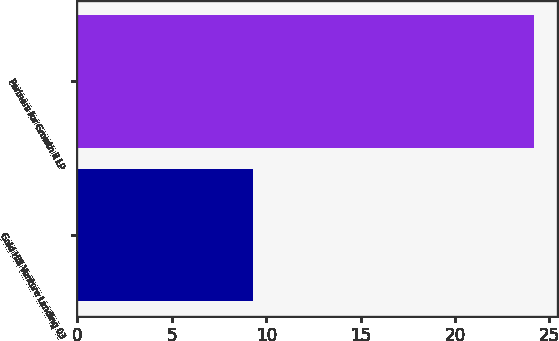<chart> <loc_0><loc_0><loc_500><loc_500><bar_chart><fcel>Gold Hill Venture Lending 03<fcel>Partners for Growth II LP<nl><fcel>9.3<fcel>24.2<nl></chart> 